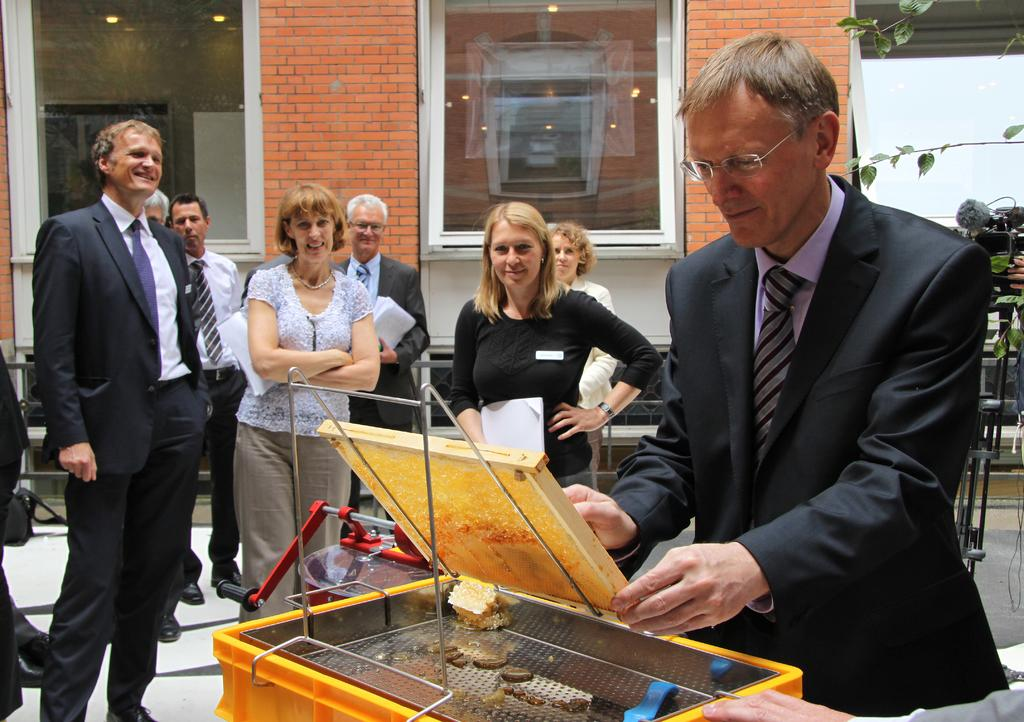What type of structures can be seen in the image? There are buildings in the image. What feature is common to many of the buildings? There are windows in the image. Can you describe the people in the image? There is a group of people in the image. What color is the wall that is visible in the image? There is a white color wall in the image. What are two persons in the group doing? Two persons are holding papers in the image. How many ladybugs can be seen crawling on the white wall in the image? There are no ladybugs present in the image; it only features buildings, windows, a group of people, and two persons holding papers. 